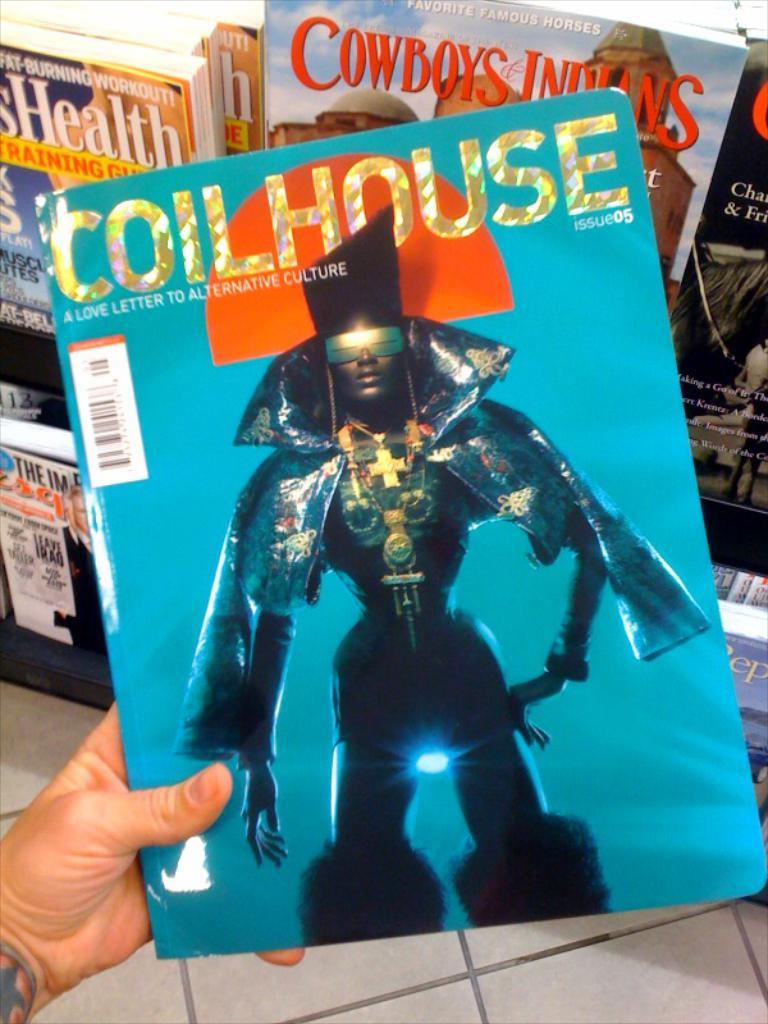<image>
Offer a succinct explanation of the picture presented. a collection of magazines, with the one in front someone is holding called COILHOUSE with an African lady dressed in odd clothing pictured. 